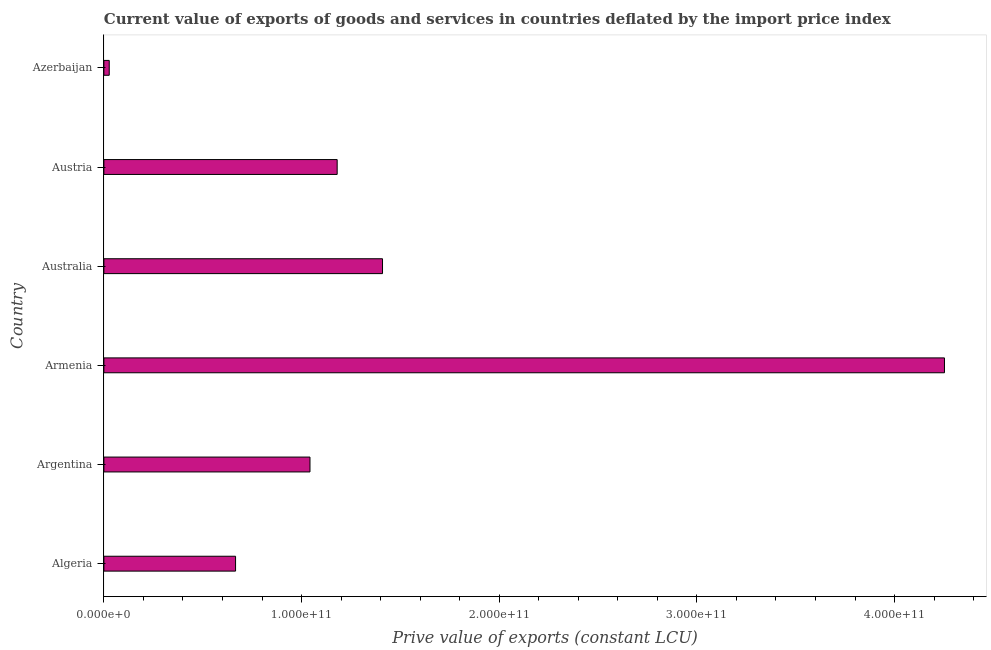Does the graph contain any zero values?
Your answer should be compact. No. What is the title of the graph?
Provide a succinct answer. Current value of exports of goods and services in countries deflated by the import price index. What is the label or title of the X-axis?
Your answer should be compact. Prive value of exports (constant LCU). What is the label or title of the Y-axis?
Ensure brevity in your answer.  Country. What is the price value of exports in Algeria?
Keep it short and to the point. 6.66e+1. Across all countries, what is the maximum price value of exports?
Give a very brief answer. 4.25e+11. Across all countries, what is the minimum price value of exports?
Ensure brevity in your answer.  2.71e+09. In which country was the price value of exports maximum?
Provide a short and direct response. Armenia. In which country was the price value of exports minimum?
Provide a succinct answer. Azerbaijan. What is the sum of the price value of exports?
Make the answer very short. 8.58e+11. What is the difference between the price value of exports in Austria and Azerbaijan?
Ensure brevity in your answer.  1.15e+11. What is the average price value of exports per country?
Make the answer very short. 1.43e+11. What is the median price value of exports?
Provide a succinct answer. 1.11e+11. What is the ratio of the price value of exports in Algeria to that in Azerbaijan?
Make the answer very short. 24.62. What is the difference between the highest and the second highest price value of exports?
Offer a terse response. 2.84e+11. Is the sum of the price value of exports in Argentina and Azerbaijan greater than the maximum price value of exports across all countries?
Your response must be concise. No. What is the difference between the highest and the lowest price value of exports?
Give a very brief answer. 4.23e+11. In how many countries, is the price value of exports greater than the average price value of exports taken over all countries?
Offer a very short reply. 1. Are all the bars in the graph horizontal?
Your answer should be very brief. Yes. What is the difference between two consecutive major ticks on the X-axis?
Give a very brief answer. 1.00e+11. Are the values on the major ticks of X-axis written in scientific E-notation?
Provide a succinct answer. Yes. What is the Prive value of exports (constant LCU) in Algeria?
Your response must be concise. 6.66e+1. What is the Prive value of exports (constant LCU) of Argentina?
Keep it short and to the point. 1.04e+11. What is the Prive value of exports (constant LCU) in Armenia?
Offer a very short reply. 4.25e+11. What is the Prive value of exports (constant LCU) in Australia?
Provide a succinct answer. 1.41e+11. What is the Prive value of exports (constant LCU) of Austria?
Provide a short and direct response. 1.18e+11. What is the Prive value of exports (constant LCU) in Azerbaijan?
Your answer should be compact. 2.71e+09. What is the difference between the Prive value of exports (constant LCU) in Algeria and Argentina?
Ensure brevity in your answer.  -3.76e+1. What is the difference between the Prive value of exports (constant LCU) in Algeria and Armenia?
Keep it short and to the point. -3.59e+11. What is the difference between the Prive value of exports (constant LCU) in Algeria and Australia?
Offer a very short reply. -7.43e+1. What is the difference between the Prive value of exports (constant LCU) in Algeria and Austria?
Keep it short and to the point. -5.14e+1. What is the difference between the Prive value of exports (constant LCU) in Algeria and Azerbaijan?
Offer a very short reply. 6.39e+1. What is the difference between the Prive value of exports (constant LCU) in Argentina and Armenia?
Your response must be concise. -3.21e+11. What is the difference between the Prive value of exports (constant LCU) in Argentina and Australia?
Your answer should be very brief. -3.67e+1. What is the difference between the Prive value of exports (constant LCU) in Argentina and Austria?
Your response must be concise. -1.38e+1. What is the difference between the Prive value of exports (constant LCU) in Argentina and Azerbaijan?
Offer a very short reply. 1.02e+11. What is the difference between the Prive value of exports (constant LCU) in Armenia and Australia?
Ensure brevity in your answer.  2.84e+11. What is the difference between the Prive value of exports (constant LCU) in Armenia and Austria?
Offer a terse response. 3.07e+11. What is the difference between the Prive value of exports (constant LCU) in Armenia and Azerbaijan?
Make the answer very short. 4.23e+11. What is the difference between the Prive value of exports (constant LCU) in Australia and Austria?
Ensure brevity in your answer.  2.29e+1. What is the difference between the Prive value of exports (constant LCU) in Australia and Azerbaijan?
Your answer should be compact. 1.38e+11. What is the difference between the Prive value of exports (constant LCU) in Austria and Azerbaijan?
Your response must be concise. 1.15e+11. What is the ratio of the Prive value of exports (constant LCU) in Algeria to that in Argentina?
Your response must be concise. 0.64. What is the ratio of the Prive value of exports (constant LCU) in Algeria to that in Armenia?
Give a very brief answer. 0.16. What is the ratio of the Prive value of exports (constant LCU) in Algeria to that in Australia?
Keep it short and to the point. 0.47. What is the ratio of the Prive value of exports (constant LCU) in Algeria to that in Austria?
Your response must be concise. 0.56. What is the ratio of the Prive value of exports (constant LCU) in Algeria to that in Azerbaijan?
Ensure brevity in your answer.  24.62. What is the ratio of the Prive value of exports (constant LCU) in Argentina to that in Armenia?
Ensure brevity in your answer.  0.24. What is the ratio of the Prive value of exports (constant LCU) in Argentina to that in Australia?
Make the answer very short. 0.74. What is the ratio of the Prive value of exports (constant LCU) in Argentina to that in Austria?
Provide a short and direct response. 0.88. What is the ratio of the Prive value of exports (constant LCU) in Argentina to that in Azerbaijan?
Offer a terse response. 38.54. What is the ratio of the Prive value of exports (constant LCU) in Armenia to that in Australia?
Keep it short and to the point. 3.02. What is the ratio of the Prive value of exports (constant LCU) in Armenia to that in Austria?
Keep it short and to the point. 3.6. What is the ratio of the Prive value of exports (constant LCU) in Armenia to that in Azerbaijan?
Your answer should be compact. 157.18. What is the ratio of the Prive value of exports (constant LCU) in Australia to that in Austria?
Make the answer very short. 1.19. What is the ratio of the Prive value of exports (constant LCU) in Australia to that in Azerbaijan?
Your answer should be very brief. 52.1. What is the ratio of the Prive value of exports (constant LCU) in Austria to that in Azerbaijan?
Offer a very short reply. 43.62. 